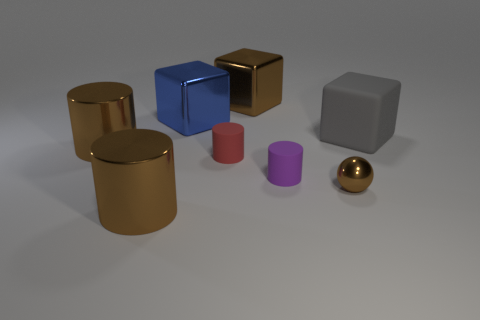Subtract all purple rubber cylinders. How many cylinders are left? 3 Subtract 1 cylinders. How many cylinders are left? 3 Subtract all purple spheres. How many brown cylinders are left? 2 Subtract all purple cylinders. How many cylinders are left? 3 Add 1 big brown shiny blocks. How many objects exist? 9 Subtract all blue cylinders. Subtract all cyan blocks. How many cylinders are left? 4 Subtract all cubes. How many objects are left? 5 Subtract 0 gray balls. How many objects are left? 8 Subtract all small red cubes. Subtract all large gray matte things. How many objects are left? 7 Add 2 large gray things. How many large gray things are left? 3 